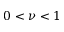Convert formula to latex. <formula><loc_0><loc_0><loc_500><loc_500>0 < \nu < 1</formula> 